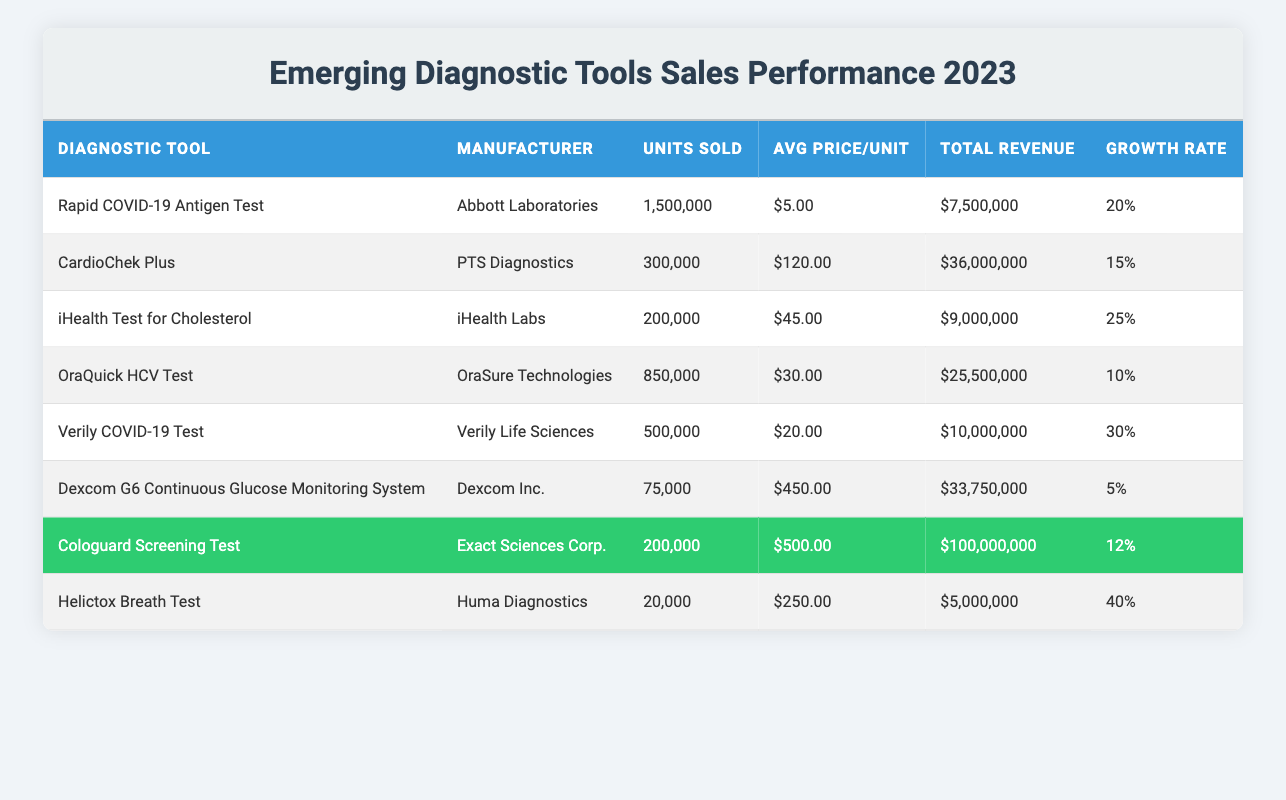What is the total revenue generated by the Cologuard Screening Test? The table indicates that the total revenue for the Cologuard Screening Test is listed directly under the "Total Revenue" column, which shows $100,000,000.
Answer: $100,000,000 How many units were sold for the Rapid COVID-19 Antigen Test? The "Units Sold" column in the table shows that 1,500,000 units of the Rapid COVID-19 Antigen Test were sold.
Answer: 1,500,000 Which diagnostic tool had the highest average price per unit? By comparing the "Avg Price/Unit" column, we find that the Dexcom G6 Continuous Glucose Monitoring System has the highest average price per unit at $450.00.
Answer: $450.00 What is the growth rate of the iHealth Test for Cholesterol? The growth rate can be directly found in the "Growth Rate" column next to the iHealth Test for Cholesterol, which shows a growth rate of 25%.
Answer: 25% Calculate the total revenue from the two COVID-19 tests combined. The total revenue for both the Rapid COVID-19 Antigen Test ($7,500,000) and the Verily COVID-19 Test ($10,000,000) needs to be summed: $7,500,000 + $10,000,000 = $17,500,000.
Answer: $17,500,000 How many units were sold for the Helictox Breath Test compared to the CardioChek Plus? The Helictox Breath Test sold 20,000 units, while the CardioChek Plus sold 300,000 units. The comparison shows that the CardioChek Plus sold significantly more units than the Helictox Breath Test.
Answer: CardioChek Plus sold more units Is the average price per unit for Cologuard Screening Test more than $400? The average price per unit for the Cologuard Screening Test is $500, which is greater than $400, making the statement true.
Answer: Yes Which diagnostic tool has the largest growth rate, and what is that rate? By examining the "Growth Rate" column, the Helictox Breath Test has the highest growth rate at 40%.
Answer: Helictox Breath Test; 40% What is the total number of units sold for all diagnostic tools? To find the total, n the "Units Sold" column: 1,500,000 + 300,000 + 200,000 + 850,000 + 500,000 + 75,000 + 200,000 + 20,000 = 3,645,000 units in total.
Answer: 3,645,000 Which manufacturer produced the diagnostic tool with the least total revenue? The table shows that the Helictox Breath Test generated $5,000,000, which is the lowest total revenue when compared to all other tools.
Answer: Huma Diagnostics (Helictox Breath Test) 